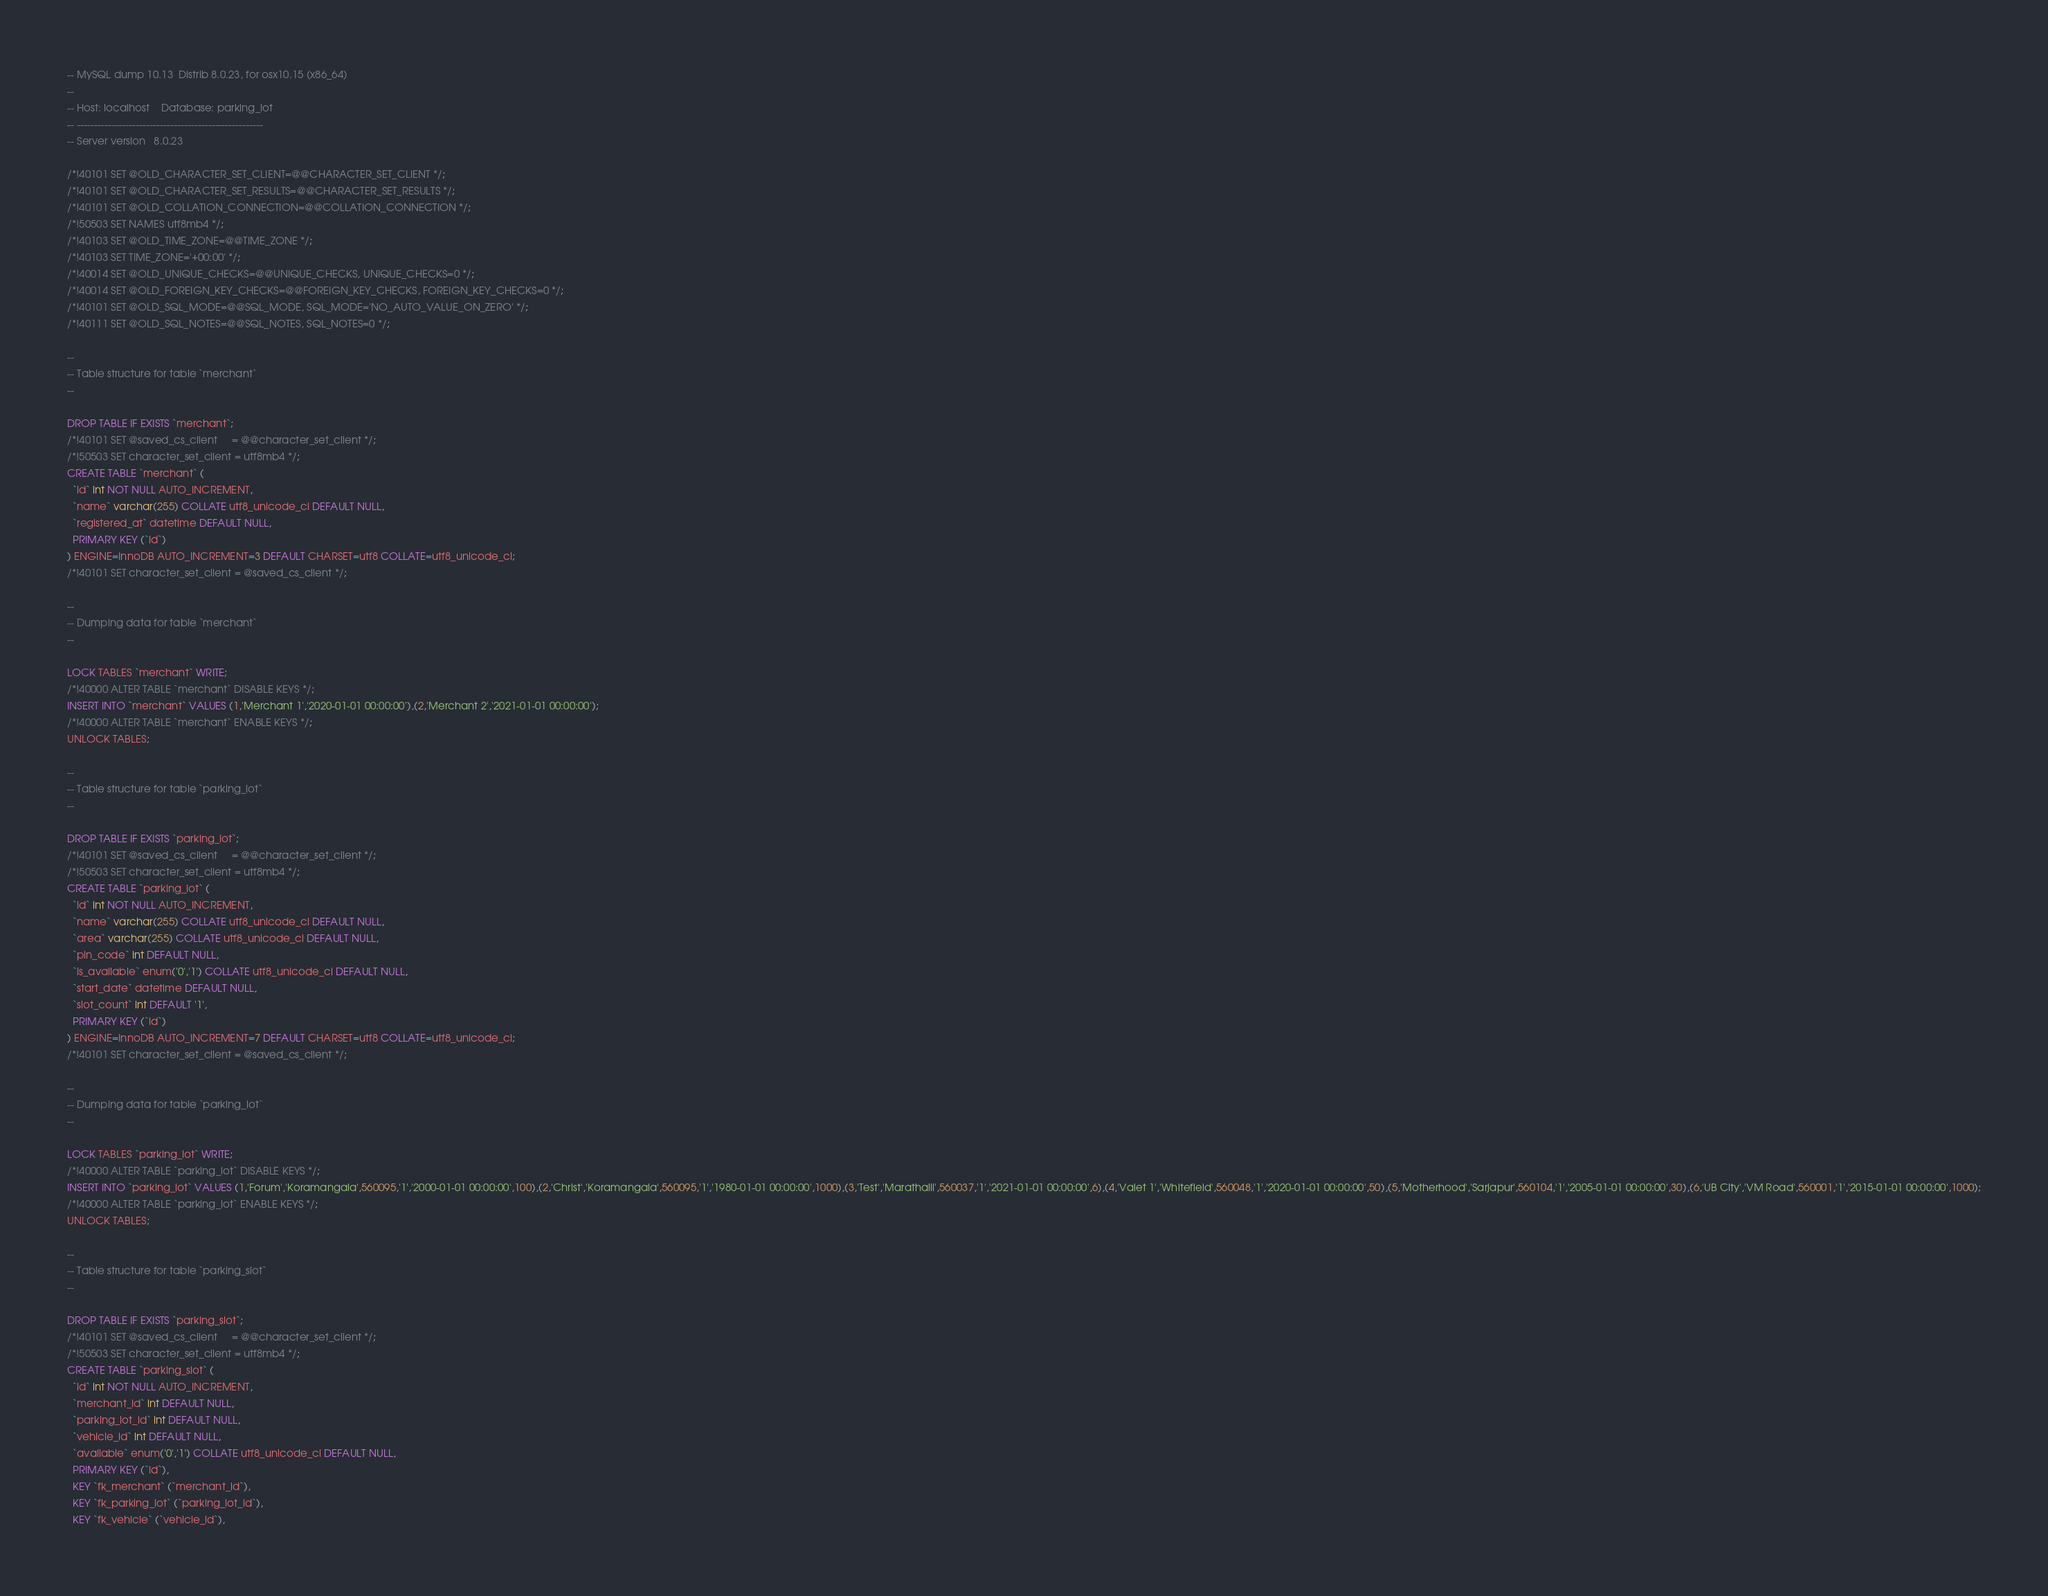Convert code to text. <code><loc_0><loc_0><loc_500><loc_500><_SQL_>-- MySQL dump 10.13  Distrib 8.0.23, for osx10.15 (x86_64)
--
-- Host: localhost    Database: parking_lot
-- ------------------------------------------------------
-- Server version	8.0.23

/*!40101 SET @OLD_CHARACTER_SET_CLIENT=@@CHARACTER_SET_CLIENT */;
/*!40101 SET @OLD_CHARACTER_SET_RESULTS=@@CHARACTER_SET_RESULTS */;
/*!40101 SET @OLD_COLLATION_CONNECTION=@@COLLATION_CONNECTION */;
/*!50503 SET NAMES utf8mb4 */;
/*!40103 SET @OLD_TIME_ZONE=@@TIME_ZONE */;
/*!40103 SET TIME_ZONE='+00:00' */;
/*!40014 SET @OLD_UNIQUE_CHECKS=@@UNIQUE_CHECKS, UNIQUE_CHECKS=0 */;
/*!40014 SET @OLD_FOREIGN_KEY_CHECKS=@@FOREIGN_KEY_CHECKS, FOREIGN_KEY_CHECKS=0 */;
/*!40101 SET @OLD_SQL_MODE=@@SQL_MODE, SQL_MODE='NO_AUTO_VALUE_ON_ZERO' */;
/*!40111 SET @OLD_SQL_NOTES=@@SQL_NOTES, SQL_NOTES=0 */;

--
-- Table structure for table `merchant`
--

DROP TABLE IF EXISTS `merchant`;
/*!40101 SET @saved_cs_client     = @@character_set_client */;
/*!50503 SET character_set_client = utf8mb4 */;
CREATE TABLE `merchant` (
  `id` int NOT NULL AUTO_INCREMENT,
  `name` varchar(255) COLLATE utf8_unicode_ci DEFAULT NULL,
  `registered_at` datetime DEFAULT NULL,
  PRIMARY KEY (`id`)
) ENGINE=InnoDB AUTO_INCREMENT=3 DEFAULT CHARSET=utf8 COLLATE=utf8_unicode_ci;
/*!40101 SET character_set_client = @saved_cs_client */;

--
-- Dumping data for table `merchant`
--

LOCK TABLES `merchant` WRITE;
/*!40000 ALTER TABLE `merchant` DISABLE KEYS */;
INSERT INTO `merchant` VALUES (1,'Merchant 1','2020-01-01 00:00:00'),(2,'Merchant 2','2021-01-01 00:00:00');
/*!40000 ALTER TABLE `merchant` ENABLE KEYS */;
UNLOCK TABLES;

--
-- Table structure for table `parking_lot`
--

DROP TABLE IF EXISTS `parking_lot`;
/*!40101 SET @saved_cs_client     = @@character_set_client */;
/*!50503 SET character_set_client = utf8mb4 */;
CREATE TABLE `parking_lot` (
  `id` int NOT NULL AUTO_INCREMENT,
  `name` varchar(255) COLLATE utf8_unicode_ci DEFAULT NULL,
  `area` varchar(255) COLLATE utf8_unicode_ci DEFAULT NULL,
  `pin_code` int DEFAULT NULL,
  `is_available` enum('0','1') COLLATE utf8_unicode_ci DEFAULT NULL,
  `start_date` datetime DEFAULT NULL,
  `slot_count` int DEFAULT '1',
  PRIMARY KEY (`id`)
) ENGINE=InnoDB AUTO_INCREMENT=7 DEFAULT CHARSET=utf8 COLLATE=utf8_unicode_ci;
/*!40101 SET character_set_client = @saved_cs_client */;

--
-- Dumping data for table `parking_lot`
--

LOCK TABLES `parking_lot` WRITE;
/*!40000 ALTER TABLE `parking_lot` DISABLE KEYS */;
INSERT INTO `parking_lot` VALUES (1,'Forum','Koramangala',560095,'1','2000-01-01 00:00:00',100),(2,'Christ','Koramangala',560095,'1','1980-01-01 00:00:00',1000),(3,'Test','Marathalli',560037,'1','2021-01-01 00:00:00',6),(4,'Valet 1','Whitefield',560048,'1','2020-01-01 00:00:00',50),(5,'Motherhood','Sarjapur',560104,'1','2005-01-01 00:00:00',30),(6,'UB City','VM Road',560001,'1','2015-01-01 00:00:00',1000);
/*!40000 ALTER TABLE `parking_lot` ENABLE KEYS */;
UNLOCK TABLES;

--
-- Table structure for table `parking_slot`
--

DROP TABLE IF EXISTS `parking_slot`;
/*!40101 SET @saved_cs_client     = @@character_set_client */;
/*!50503 SET character_set_client = utf8mb4 */;
CREATE TABLE `parking_slot` (
  `id` int NOT NULL AUTO_INCREMENT,
  `merchant_id` int DEFAULT NULL,
  `parking_lot_id` int DEFAULT NULL,
  `vehicle_id` int DEFAULT NULL,
  `available` enum('0','1') COLLATE utf8_unicode_ci DEFAULT NULL,
  PRIMARY KEY (`id`),
  KEY `fk_merchant` (`merchant_id`),
  KEY `fk_parking_lot` (`parking_lot_id`),
  KEY `fk_vehicle` (`vehicle_id`),</code> 